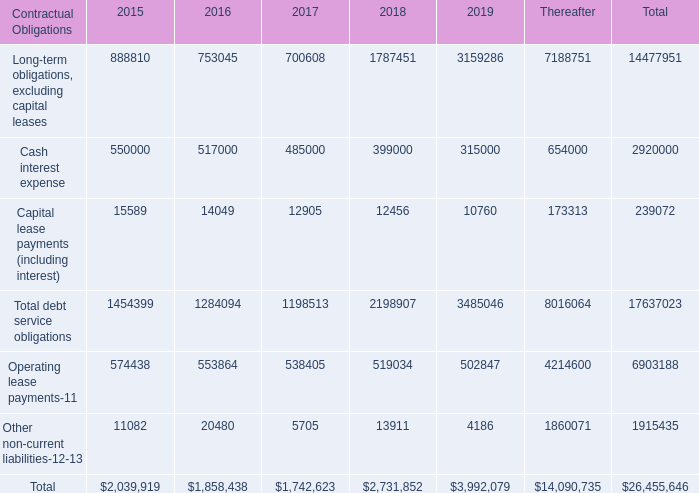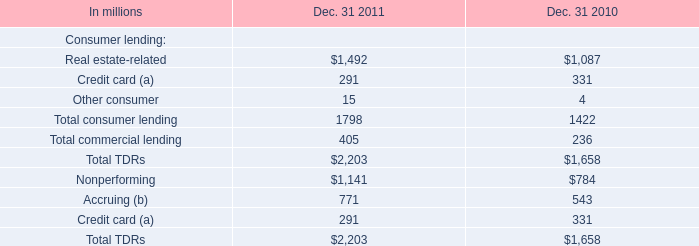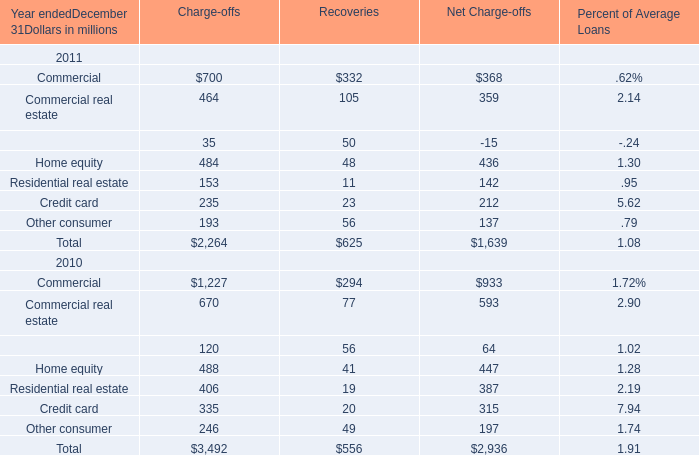What was the total amount of Real estate-related greater than1 in 2010 and 2011 ? 
Computations: (1492 + 1087)
Answer: 2579.0. 